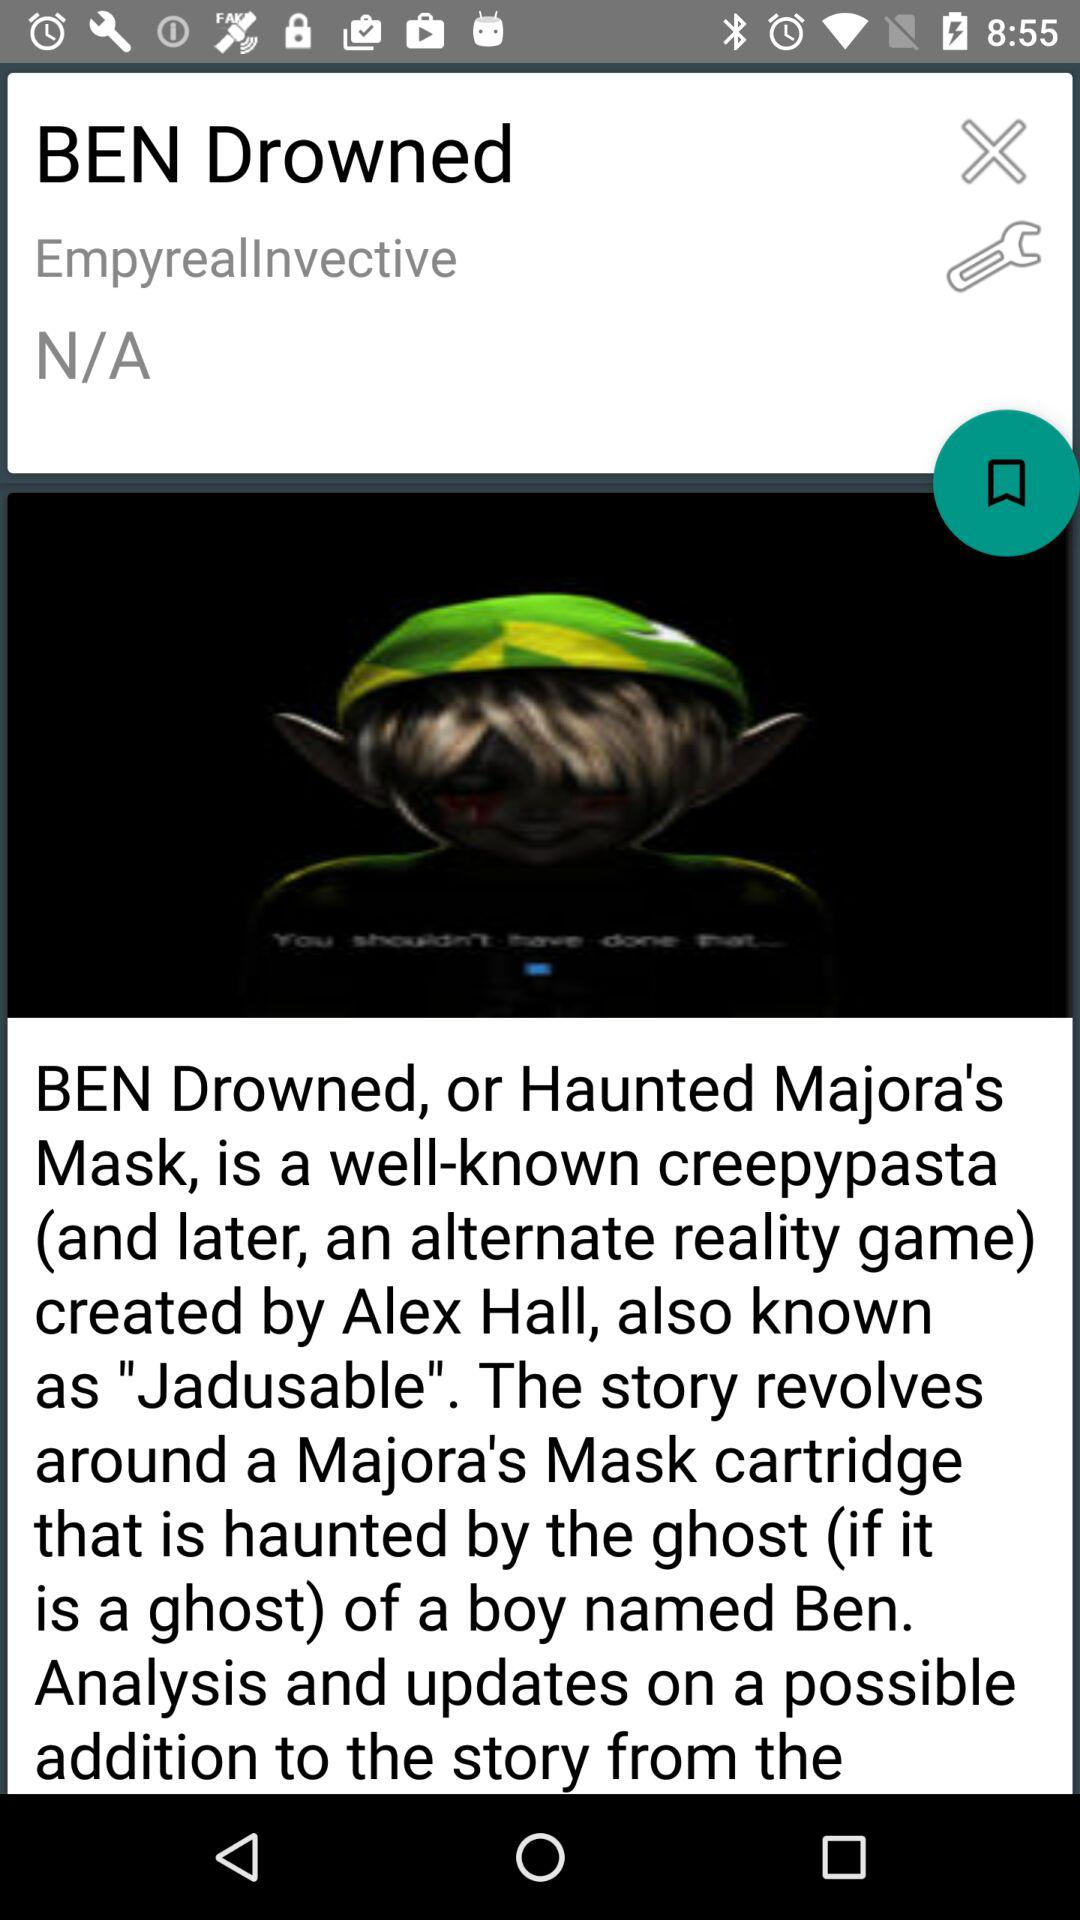What is the name of the boy? The name of the boy is Ben. 